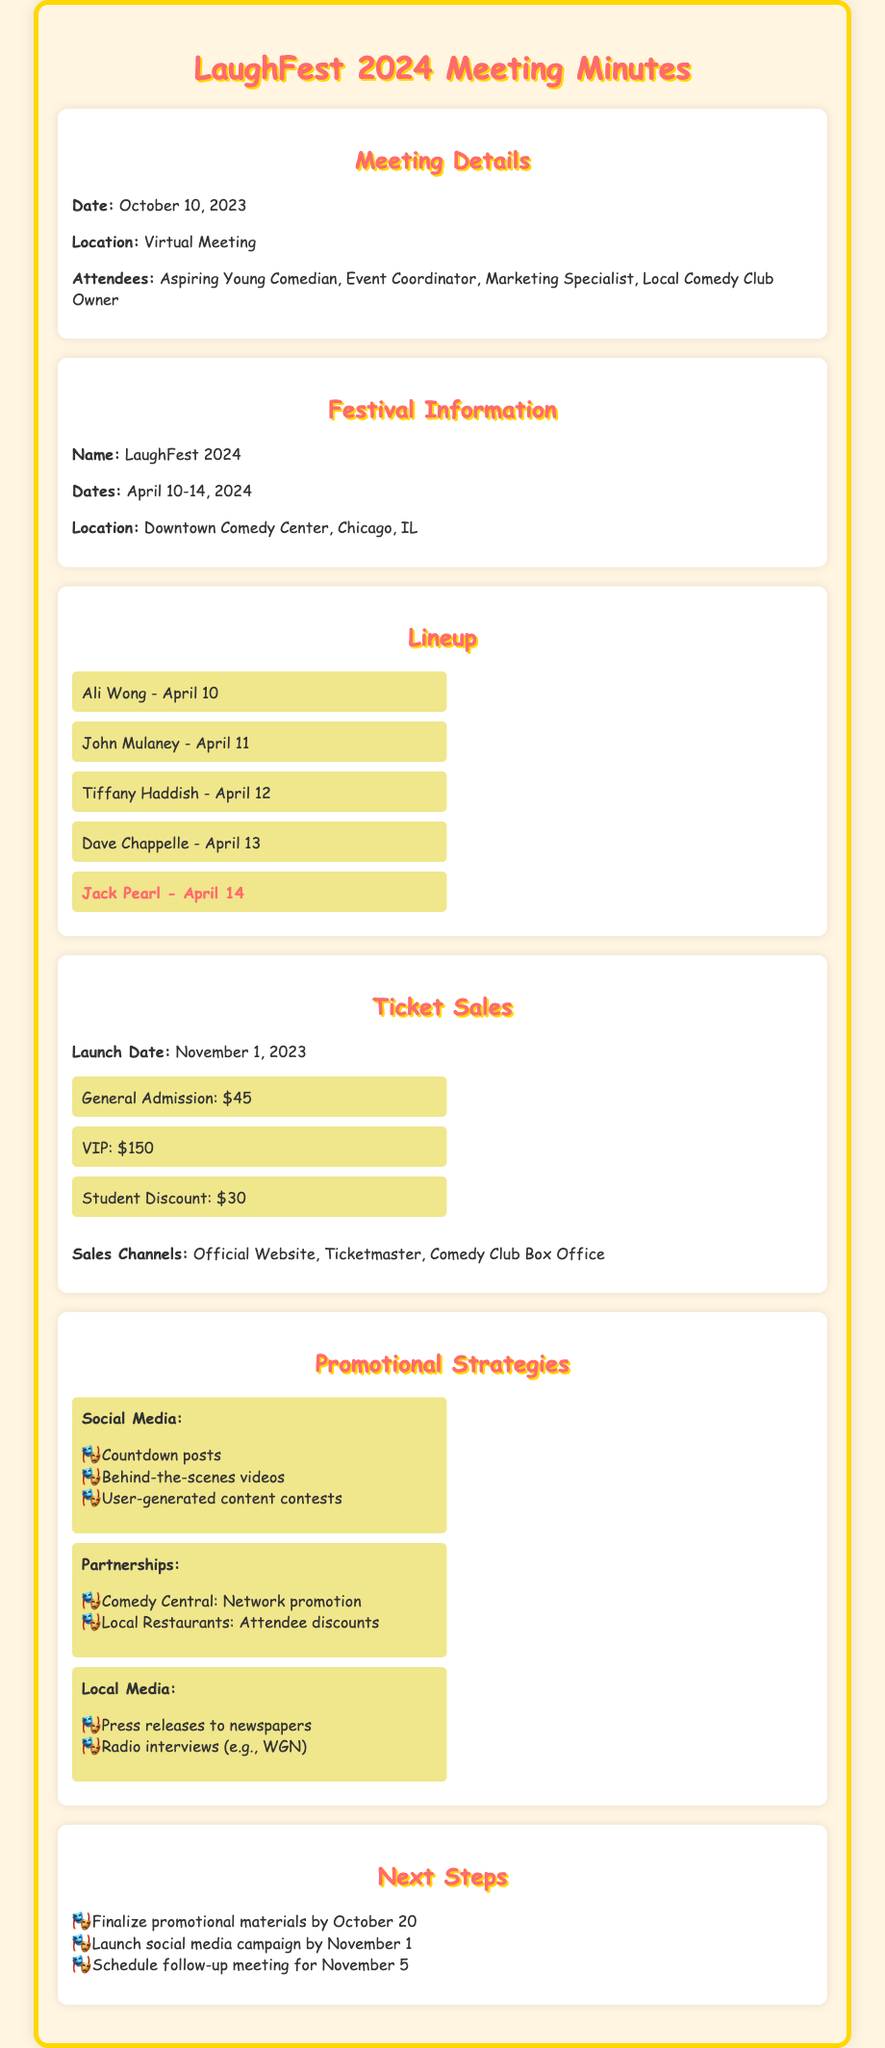What are the dates of LaughFest 2024? The dates are listed clearly in the document, specifying the festival period.
Answer: April 10-14, 2024 Who is performing on April 14? The document explicitly names the performer for that date.
Answer: Jack Pearl What is the ticket price for General Admission? Ticket pricing details are provided in the section on ticket sales.
Answer: $45 When will ticket sales launch? The launch date is mentioned in the ticket sales section of the document.
Answer: November 1, 2023 What is one strategy mentioned for social media promotion? The document lists strategies for social media promotion, providing examples.
Answer: Countdown posts How many attendees are expected at the festival? The document does not provide a specific number for expected attendees, making this a reasoning question.
Answer: N/A What is the location of the festival? The location is specified in the festival information section.
Answer: Downtown Comedy Center, Chicago, IL What is one partnership mentioned for promotions? The document mentions specific partnerships for promotional strategies.
Answer: Comedy Central 